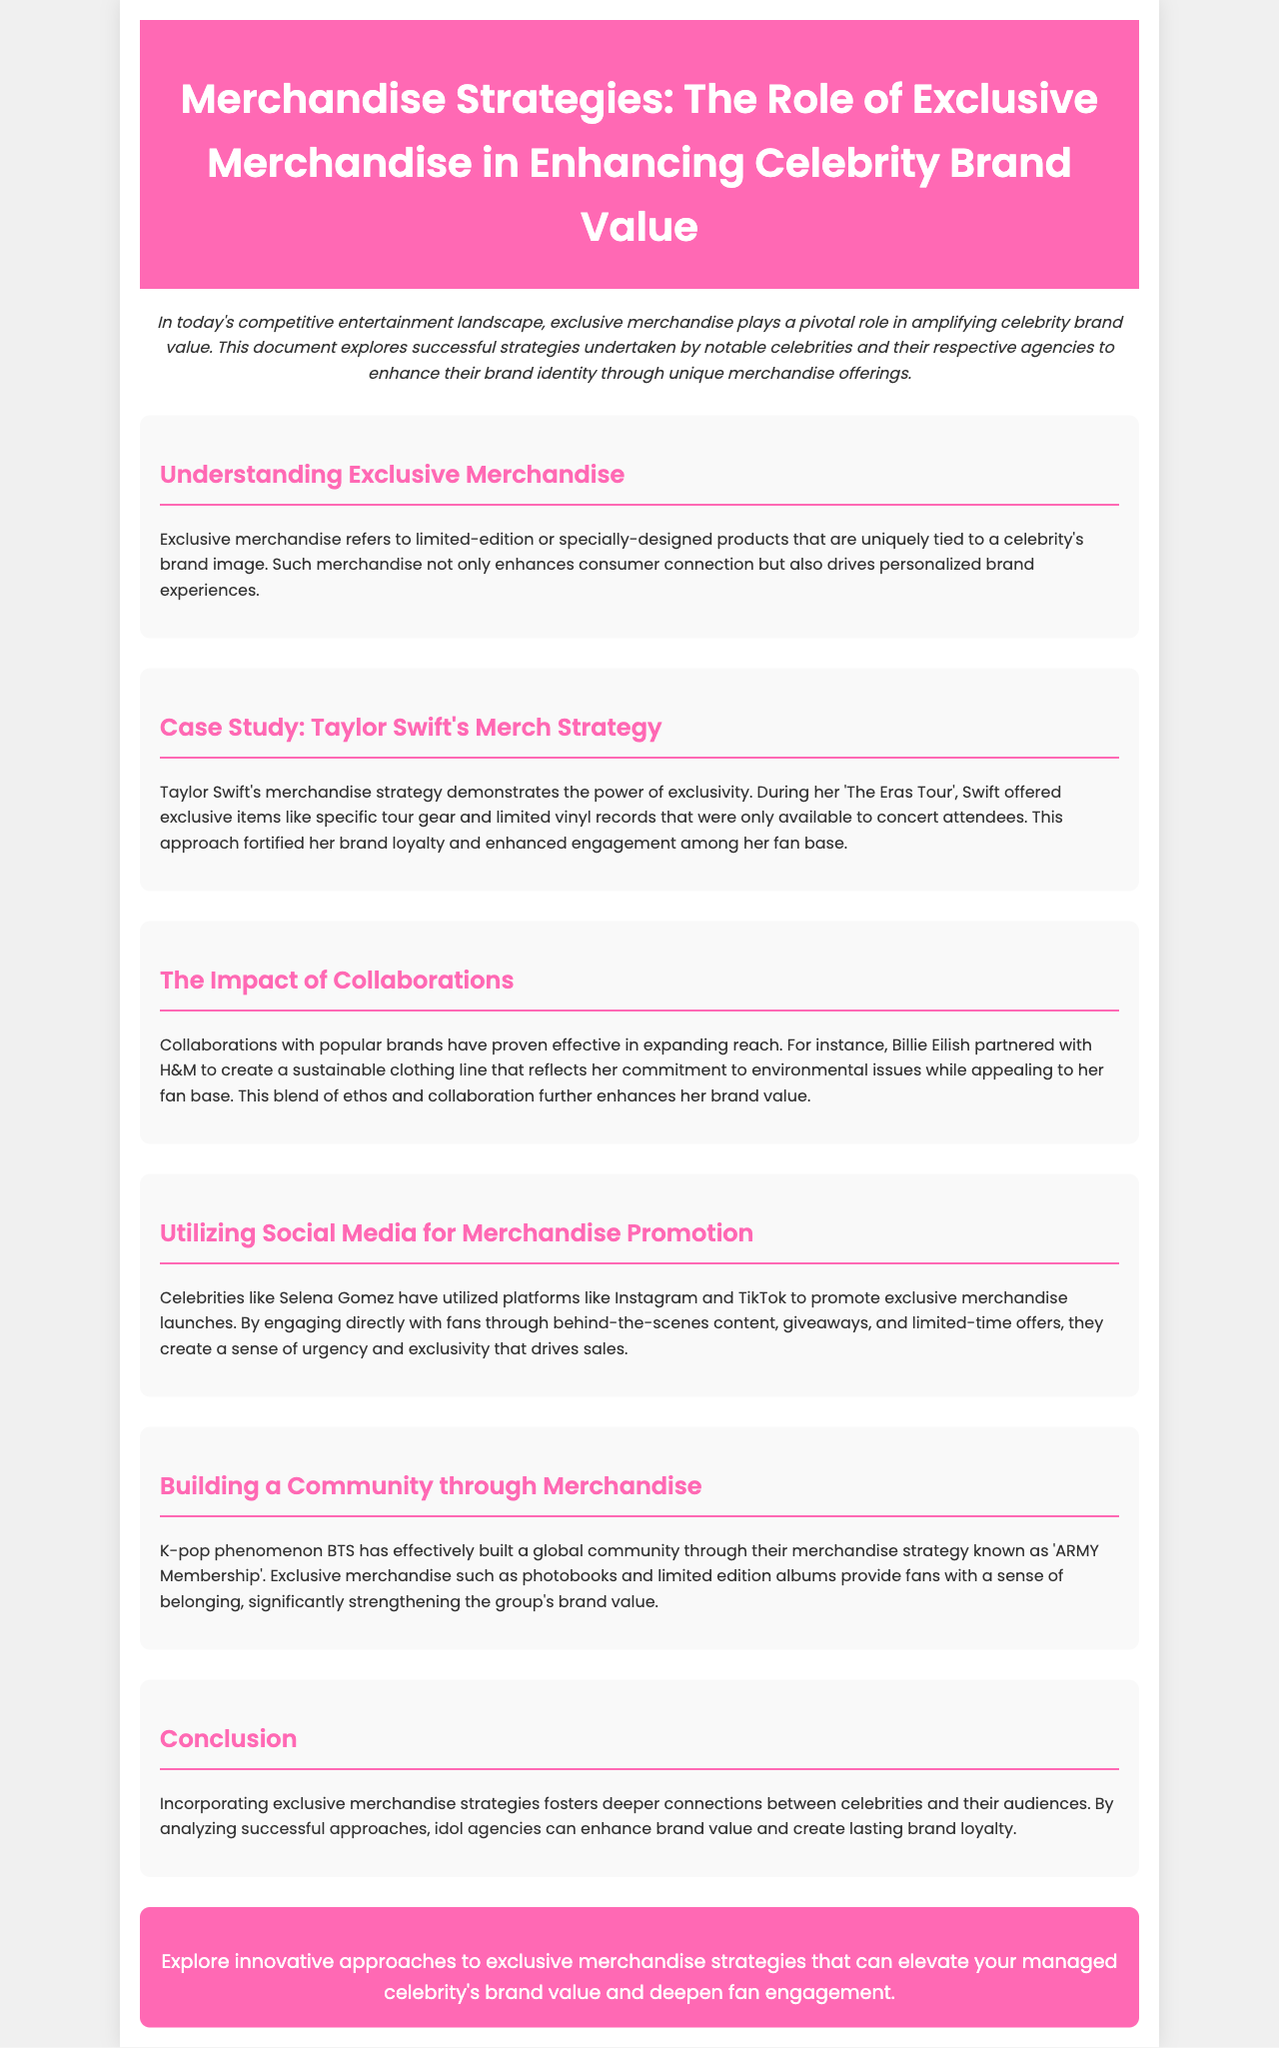what is the primary focus of the brochure? The brochure primarily focuses on how exclusive merchandise enhances celebrity brand value.
Answer: exclusive merchandise who is the case study subject for merchandise strategy? The case study highlights a specific celebrity known for her effective merchandise strategy.
Answer: Taylor Swift what unique items were offered during 'The Eras Tour'? This refers specifically to the merchandise provided exclusively at the tour.
Answer: tour gear and limited vinyl records which celebrity partnered with H&M for a merchandise strategy? The document mentions a specific celebrity who collaborated with a well-known brand.
Answer: Billie Eilish what social media platforms are mentioned for merchandise promotion? The text identifies specific social media platforms used for promoting merchandise.
Answer: Instagram and TikTok what is the name of BTS's merchandise community strategy? The document specifies the name of the community strategy utilized by BTS.
Answer: ARMY Membership how does exclusive merchandise impact brand loyalty? This question requires understanding the relationship between merchandise and consumer connection.
Answer: it strengthens brand loyalty what is the main takeaway from the document’s conclusion? The conclusion summarizes the effect of exclusive merchandise on celebrity-audience connections.
Answer: deeper connections how does the brochure encourage agencies? The brochure suggests a specific action for agencies aiming to enhance celebrity branding.
Answer: explore innovative approaches 